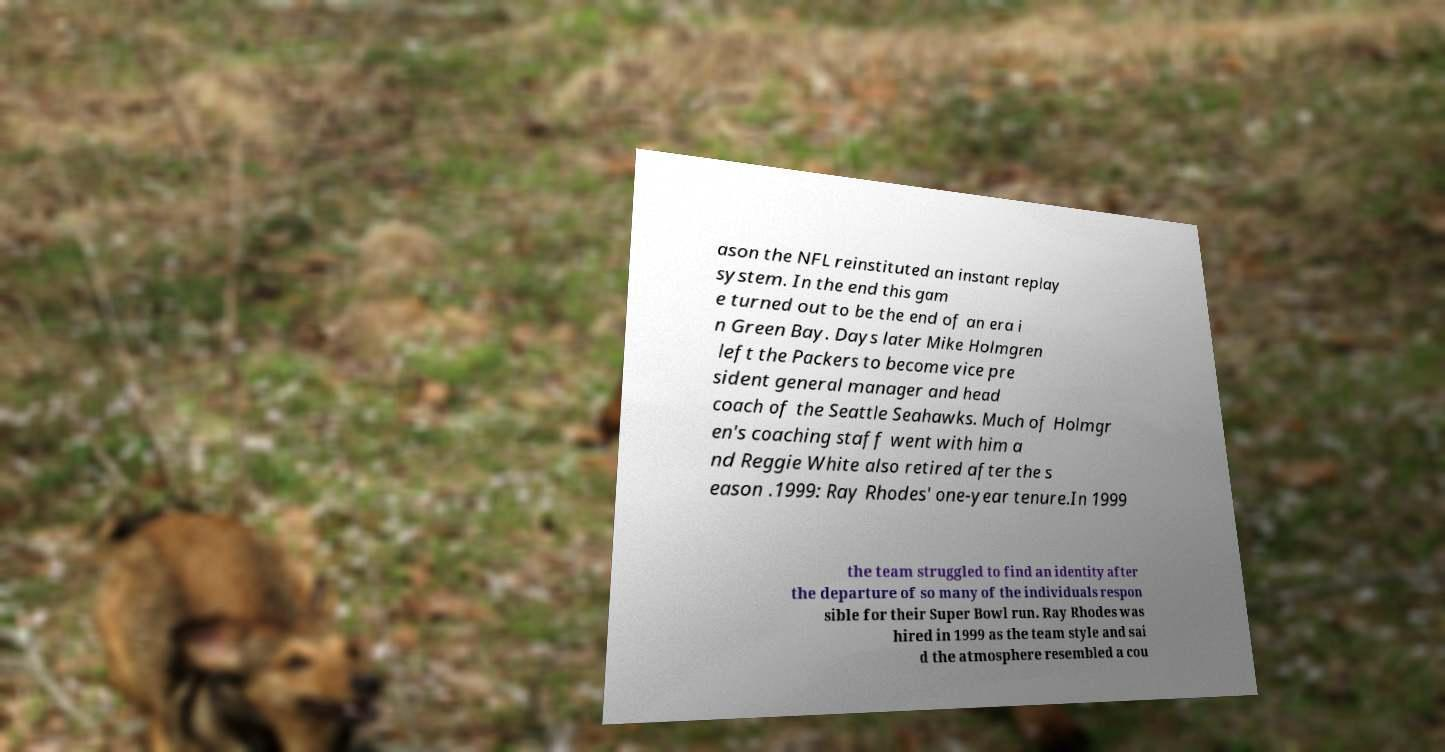Can you read and provide the text displayed in the image?This photo seems to have some interesting text. Can you extract and type it out for me? ason the NFL reinstituted an instant replay system. In the end this gam e turned out to be the end of an era i n Green Bay. Days later Mike Holmgren left the Packers to become vice pre sident general manager and head coach of the Seattle Seahawks. Much of Holmgr en's coaching staff went with him a nd Reggie White also retired after the s eason .1999: Ray Rhodes' one-year tenure.In 1999 the team struggled to find an identity after the departure of so many of the individuals respon sible for their Super Bowl run. Ray Rhodes was hired in 1999 as the team style and sai d the atmosphere resembled a cou 